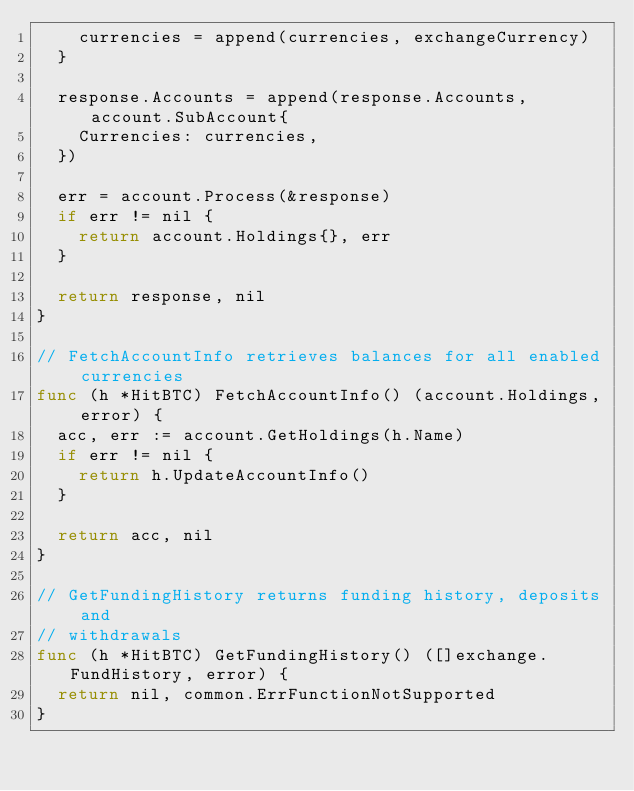Convert code to text. <code><loc_0><loc_0><loc_500><loc_500><_Go_>		currencies = append(currencies, exchangeCurrency)
	}

	response.Accounts = append(response.Accounts, account.SubAccount{
		Currencies: currencies,
	})

	err = account.Process(&response)
	if err != nil {
		return account.Holdings{}, err
	}

	return response, nil
}

// FetchAccountInfo retrieves balances for all enabled currencies
func (h *HitBTC) FetchAccountInfo() (account.Holdings, error) {
	acc, err := account.GetHoldings(h.Name)
	if err != nil {
		return h.UpdateAccountInfo()
	}

	return acc, nil
}

// GetFundingHistory returns funding history, deposits and
// withdrawals
func (h *HitBTC) GetFundingHistory() ([]exchange.FundHistory, error) {
	return nil, common.ErrFunctionNotSupported
}
</code> 